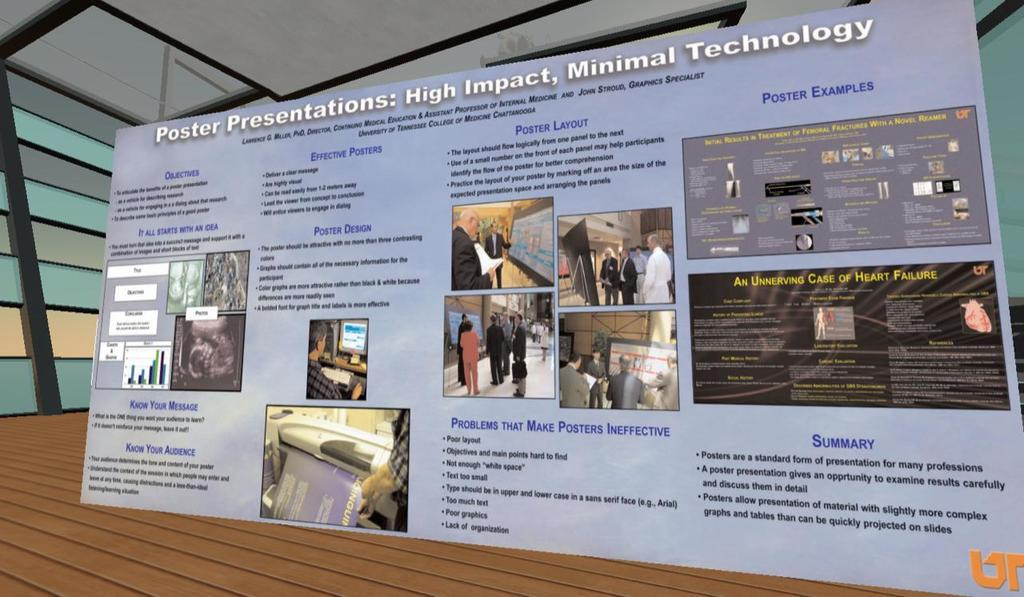<image>
Provide a brief description of the given image. a large posterboard with poster presentations on it 